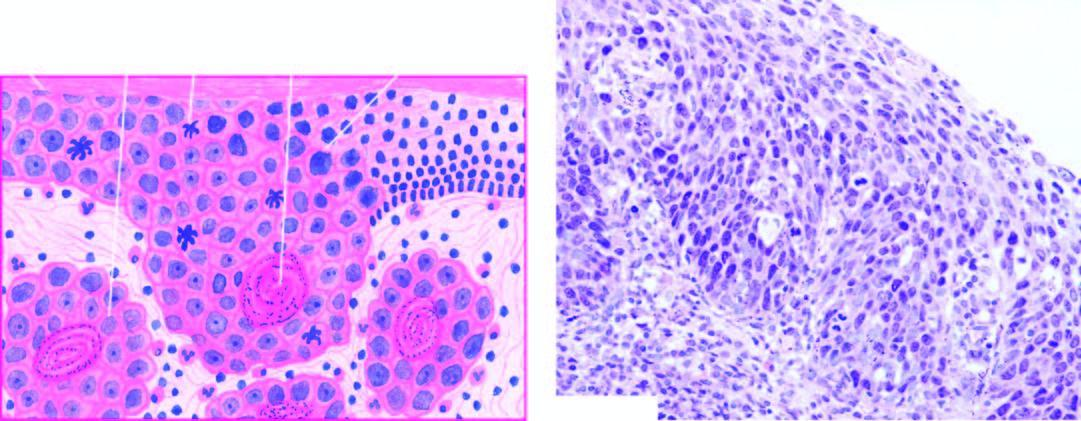what do a few areas show?
Answer the question using a single word or phrase. Superficial invasive islands of malignant cells 